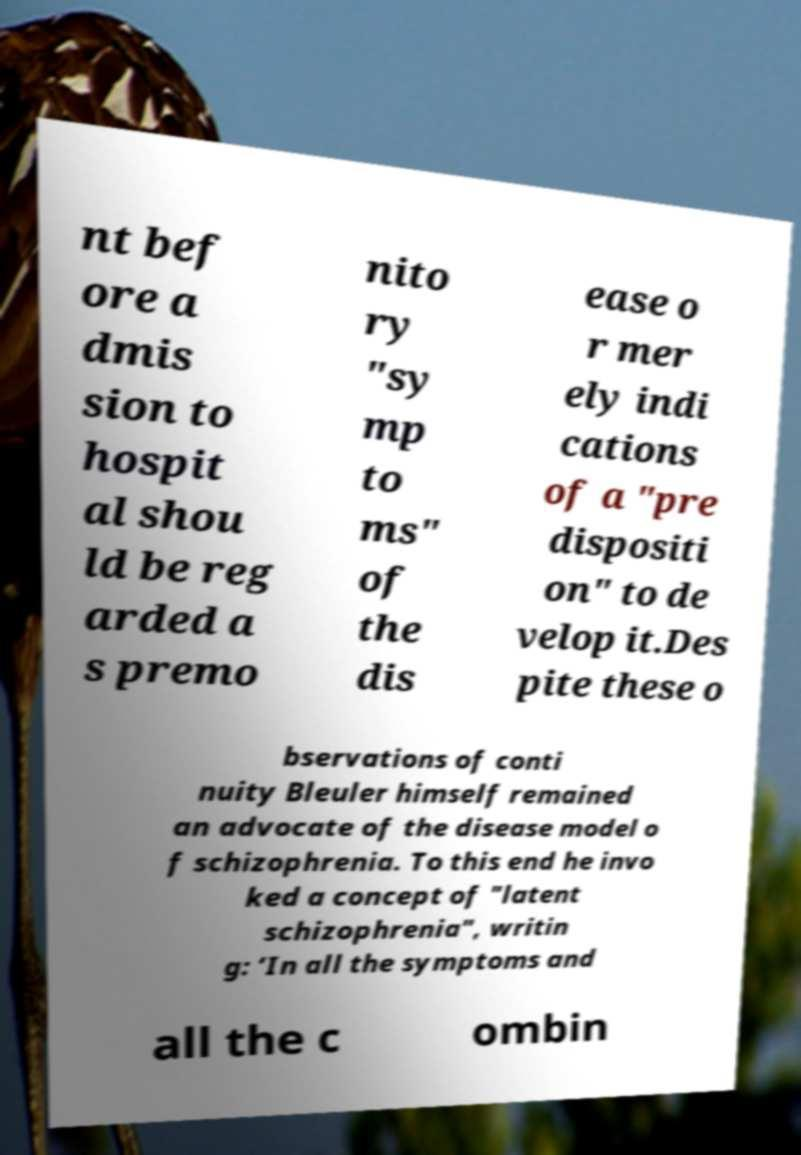Can you read and provide the text displayed in the image?This photo seems to have some interesting text. Can you extract and type it out for me? nt bef ore a dmis sion to hospit al shou ld be reg arded a s premo nito ry "sy mp to ms" of the dis ease o r mer ely indi cations of a "pre dispositi on" to de velop it.Des pite these o bservations of conti nuity Bleuler himself remained an advocate of the disease model o f schizophrenia. To this end he invo ked a concept of "latent schizophrenia", writin g: ‘In all the symptoms and all the c ombin 